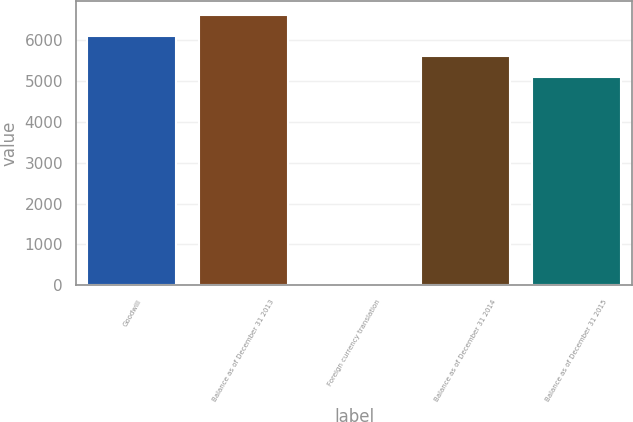<chart> <loc_0><loc_0><loc_500><loc_500><bar_chart><fcel>Goodwill<fcel>Balance as of December 31 2013<fcel>Foreign currency translation<fcel>Balance as of December 31 2014<fcel>Balance as of December 31 2015<nl><fcel>6112.8<fcel>6625.7<fcel>55<fcel>5599.9<fcel>5087<nl></chart> 